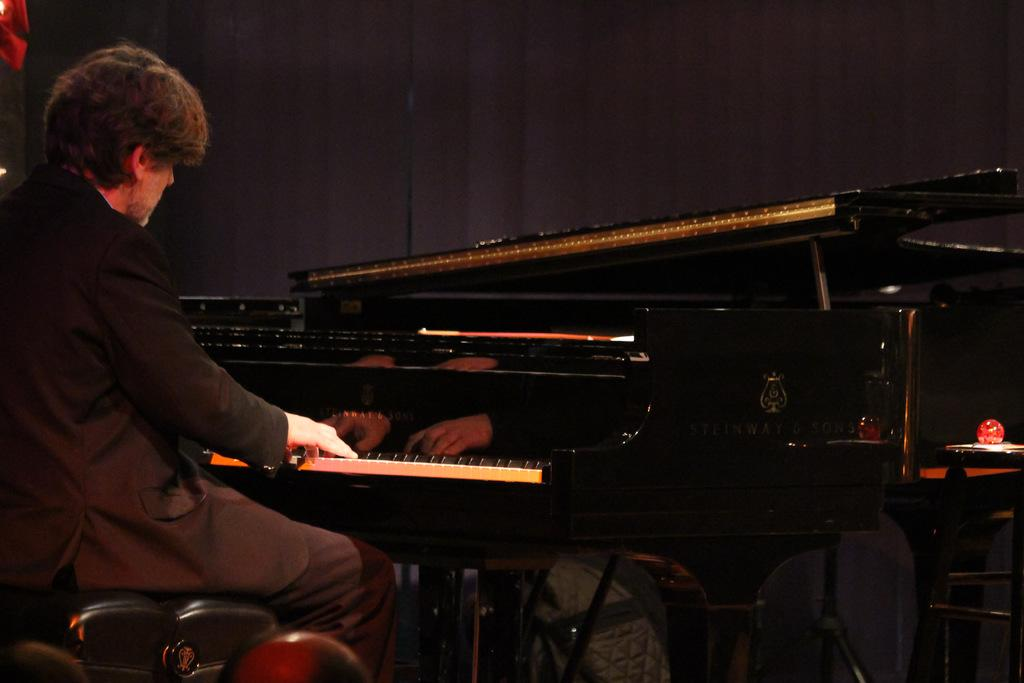Who is present in the image? There is a man in the image. What is the man doing in the image? The man is sitting in the image. What object is in front of the man? The man is in front of a piano. How many dogs are visible in the image? There are no dogs present in the image. What type of polish is the man applying to his hands in the image? There is no indication that the man is applying any polish to his hands in the image. 